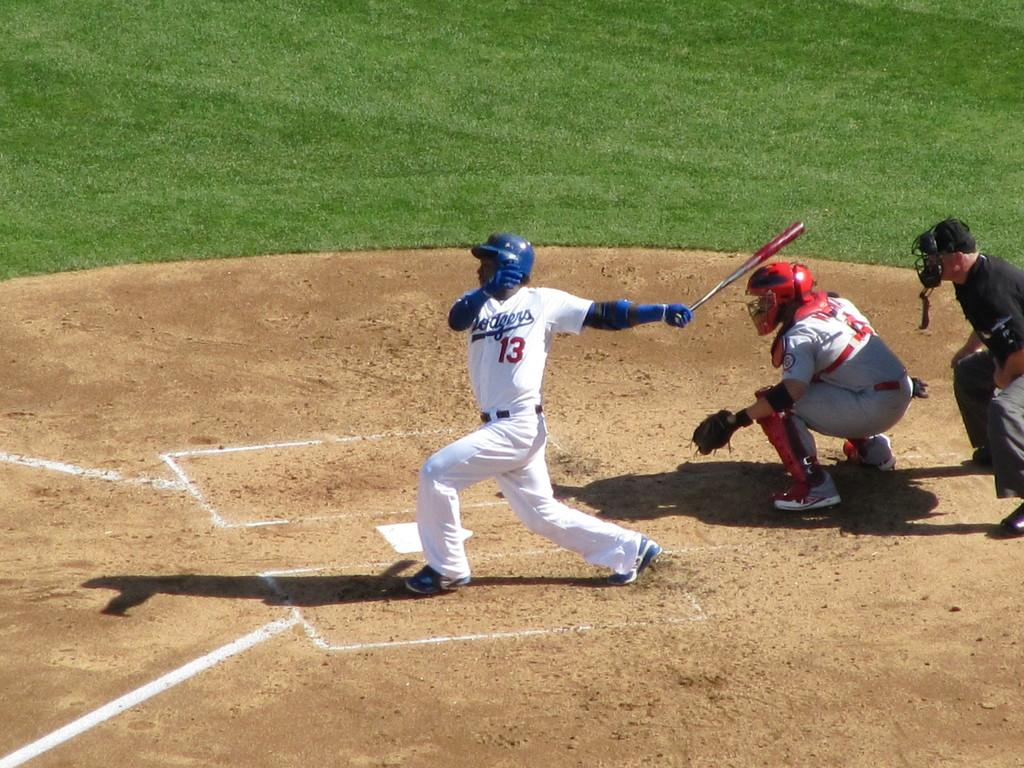How many people are in the image? There are people in the image, but the exact number is not specified. What are the people on the ground doing? Some of the people are on the ground, but their activities are not described. What type of clothing are some of the people wearing? Some people are wearing sports dress. What protective gear are some people wearing? Some people are wearing helmets. What object is one person holding? One person is holding a bat. What type of flowers can be seen growing near the people in the image? There is no mention of flowers in the image, so it is not possible to answer that question. 